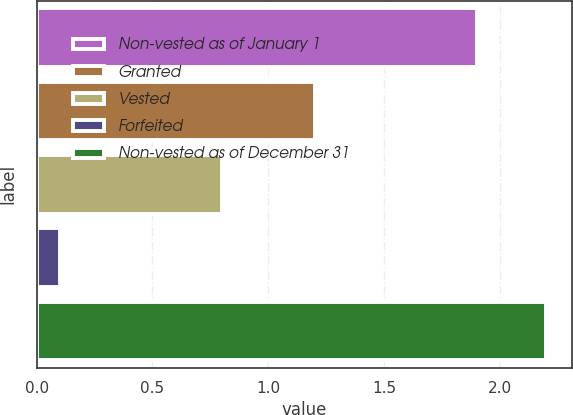<chart> <loc_0><loc_0><loc_500><loc_500><bar_chart><fcel>Non-vested as of January 1<fcel>Granted<fcel>Vested<fcel>Forfeited<fcel>Non-vested as of December 31<nl><fcel>1.9<fcel>1.2<fcel>0.8<fcel>0.1<fcel>2.2<nl></chart> 